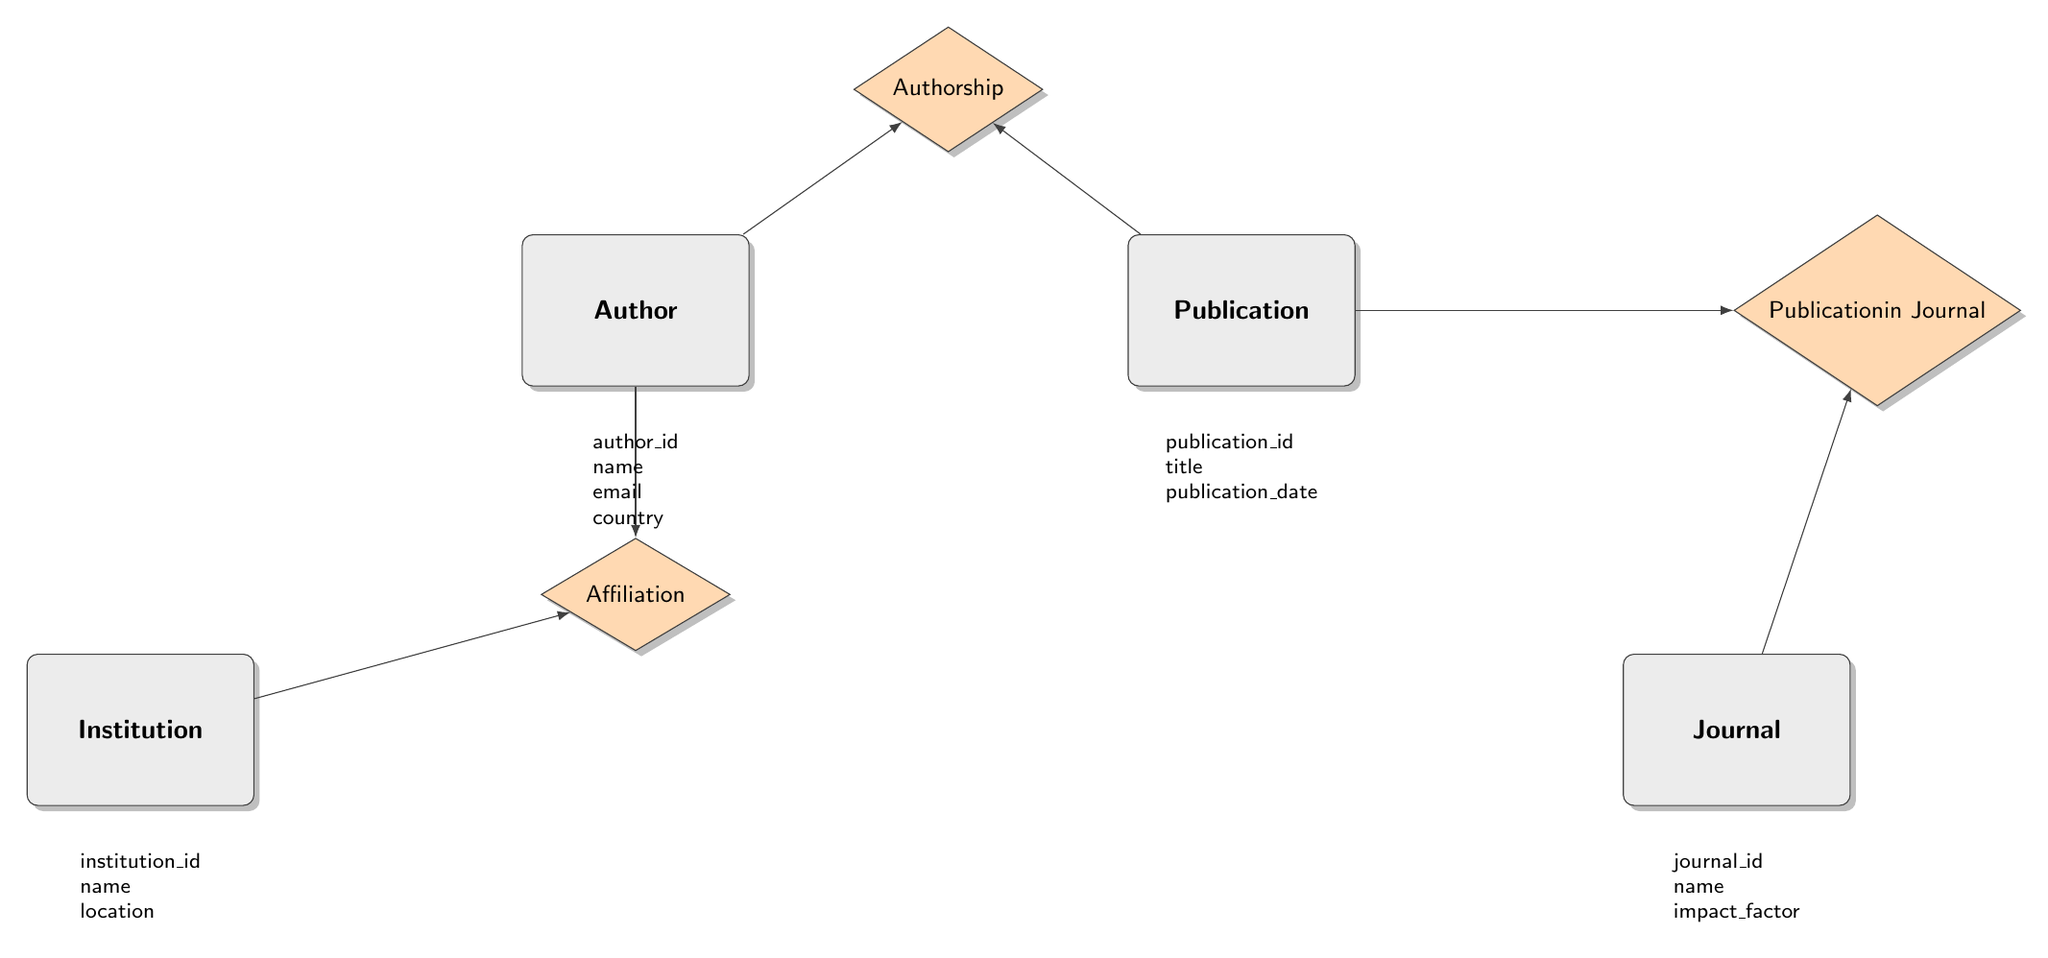What entities are present in this diagram? The diagram presents four entities: Author, Publication, Journal, and Institution.
Answer: Author, Publication, Journal, Institution How many attributes does the Author entity have? The Author entity has four attributes: author_id, name, email, and country.
Answer: Four What is the impact factor of the Ethnomusicology Review journal? The Ethnomusicology Review journal has an impact factor of 3.1, as shown in the Journal entity section.
Answer: 3.1 Which relationship connects the Author and Publication entities? The relationship connecting the Author and Publication entities is called "Authorship." It is labeled in the diagram and shows their connection.
Answer: Authorship Which institution is Dr. Aigul Khasenova affiliated with? Dr. Aigul Khasenova has an affiliation with Al-Farabi Kazakh National University, which is noted in the Affiliation relationship.
Answer: Al-Farabi Kazakh National University What is the publication date of "Modern Trends in Ethnomusicology"? The publication date of "Modern Trends in Ethnomusicology" is noted as 2019-11-23 in the Publication entity examples.
Answer: 2019-11-23 How many relationships are depicted in this diagram? There are three relationships depicted in this diagram: Authorship, Affiliation, and Publication in Journal. Counting them confirms that.
Answer: Three Which publication is linked to the Journal of Central Asian Music Studies? "The Evolution of Kazakh Folk Music" is linked to the Journal of Central Asian Music Studies, as shown in the PublicationInJournal relationship examples.
Answer: The Evolution of Kazakh Folk Music How many institutions are listed in the diagram? There are two institutions listed in the diagram: Al-Farabi Kazakh National University and Nazarbayev University. This is evident from the Institution entity section.
Answer: Two 